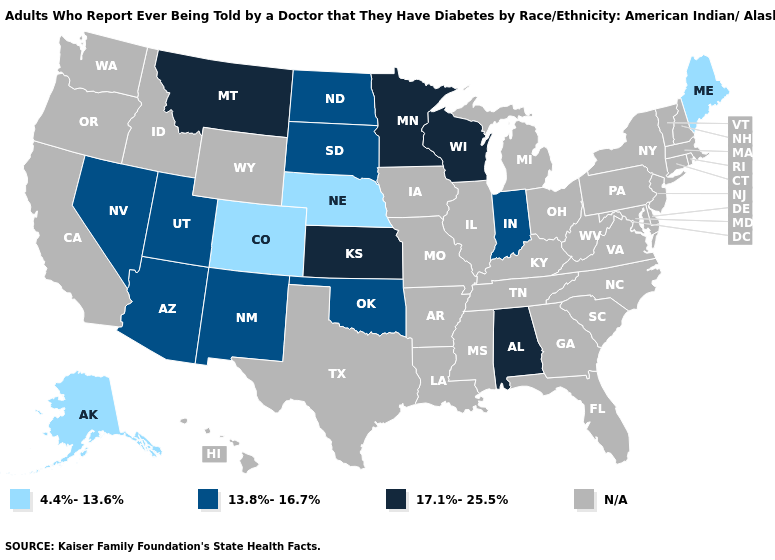Name the states that have a value in the range 4.4%-13.6%?
Write a very short answer. Alaska, Colorado, Maine, Nebraska. Name the states that have a value in the range 13.8%-16.7%?
Give a very brief answer. Arizona, Indiana, Nevada, New Mexico, North Dakota, Oklahoma, South Dakota, Utah. Does Alabama have the highest value in the USA?
Be succinct. Yes. What is the value of Ohio?
Write a very short answer. N/A. Name the states that have a value in the range 17.1%-25.5%?
Quick response, please. Alabama, Kansas, Minnesota, Montana, Wisconsin. What is the lowest value in the Northeast?
Write a very short answer. 4.4%-13.6%. What is the value of Maryland?
Answer briefly. N/A. Which states have the lowest value in the USA?
Concise answer only. Alaska, Colorado, Maine, Nebraska. Does South Dakota have the lowest value in the MidWest?
Concise answer only. No. Which states have the lowest value in the USA?
Concise answer only. Alaska, Colorado, Maine, Nebraska. Does North Dakota have the lowest value in the USA?
Give a very brief answer. No. What is the value of Nebraska?
Keep it brief. 4.4%-13.6%. What is the lowest value in the South?
Quick response, please. 13.8%-16.7%. What is the value of Alaska?
Be succinct. 4.4%-13.6%. 